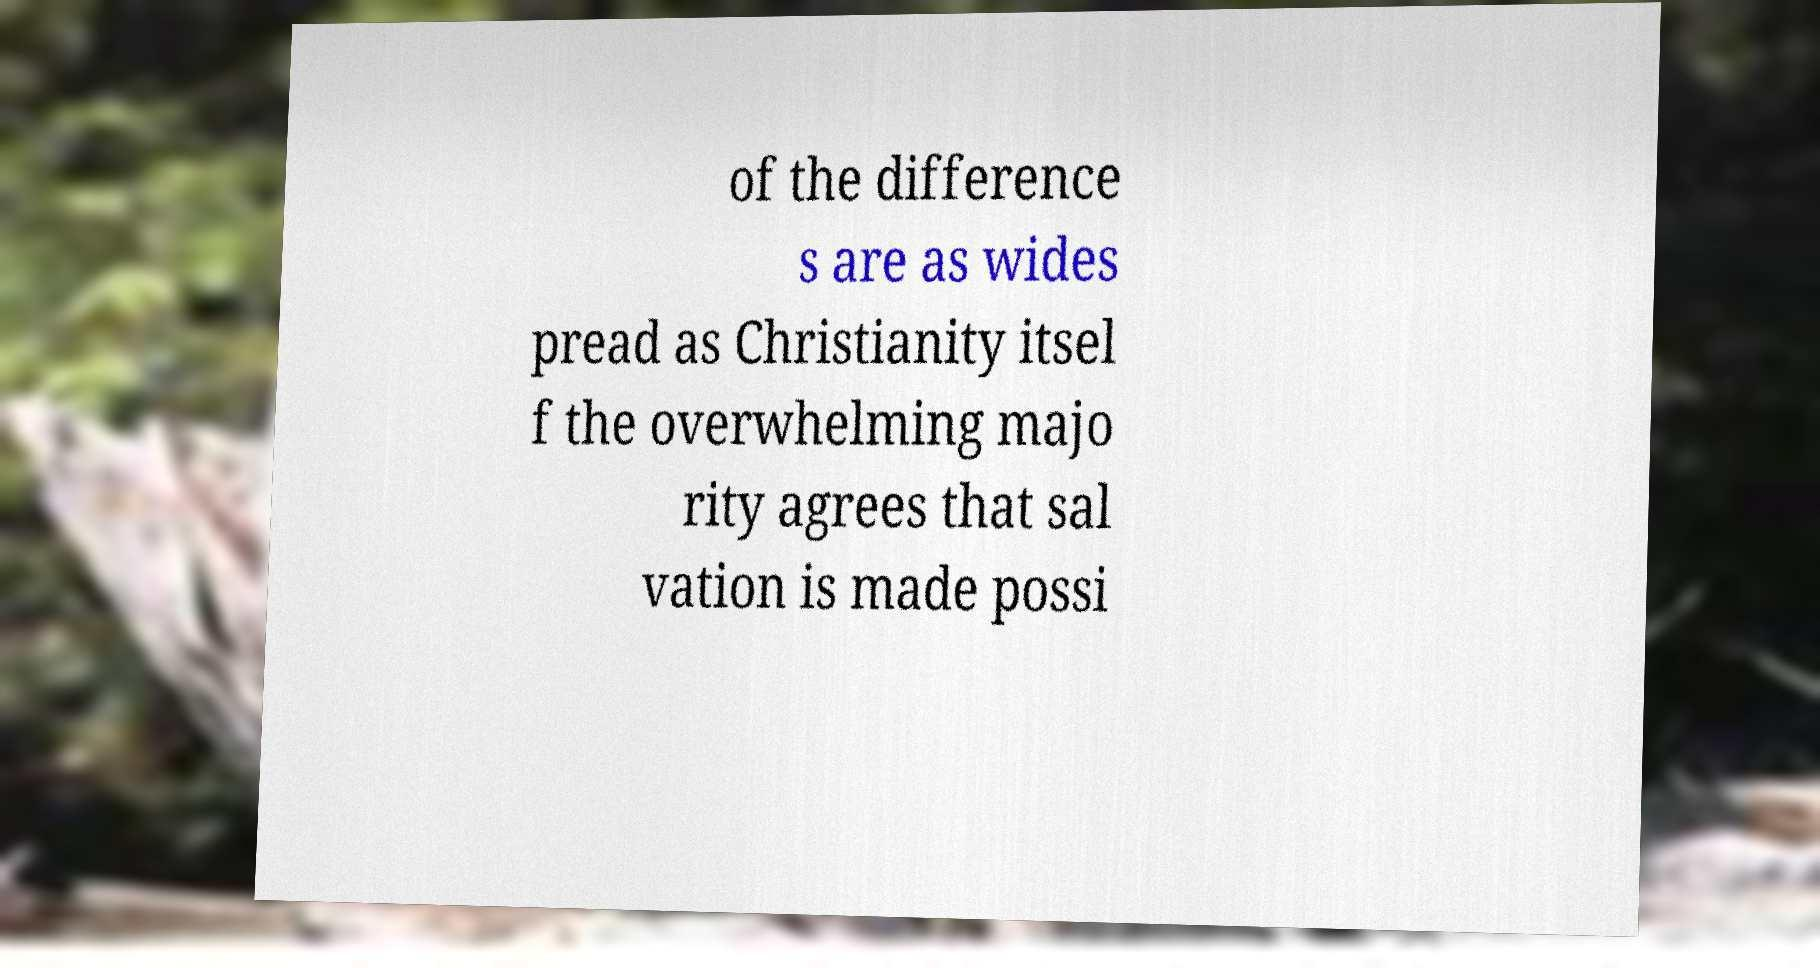I need the written content from this picture converted into text. Can you do that? of the difference s are as wides pread as Christianity itsel f the overwhelming majo rity agrees that sal vation is made possi 